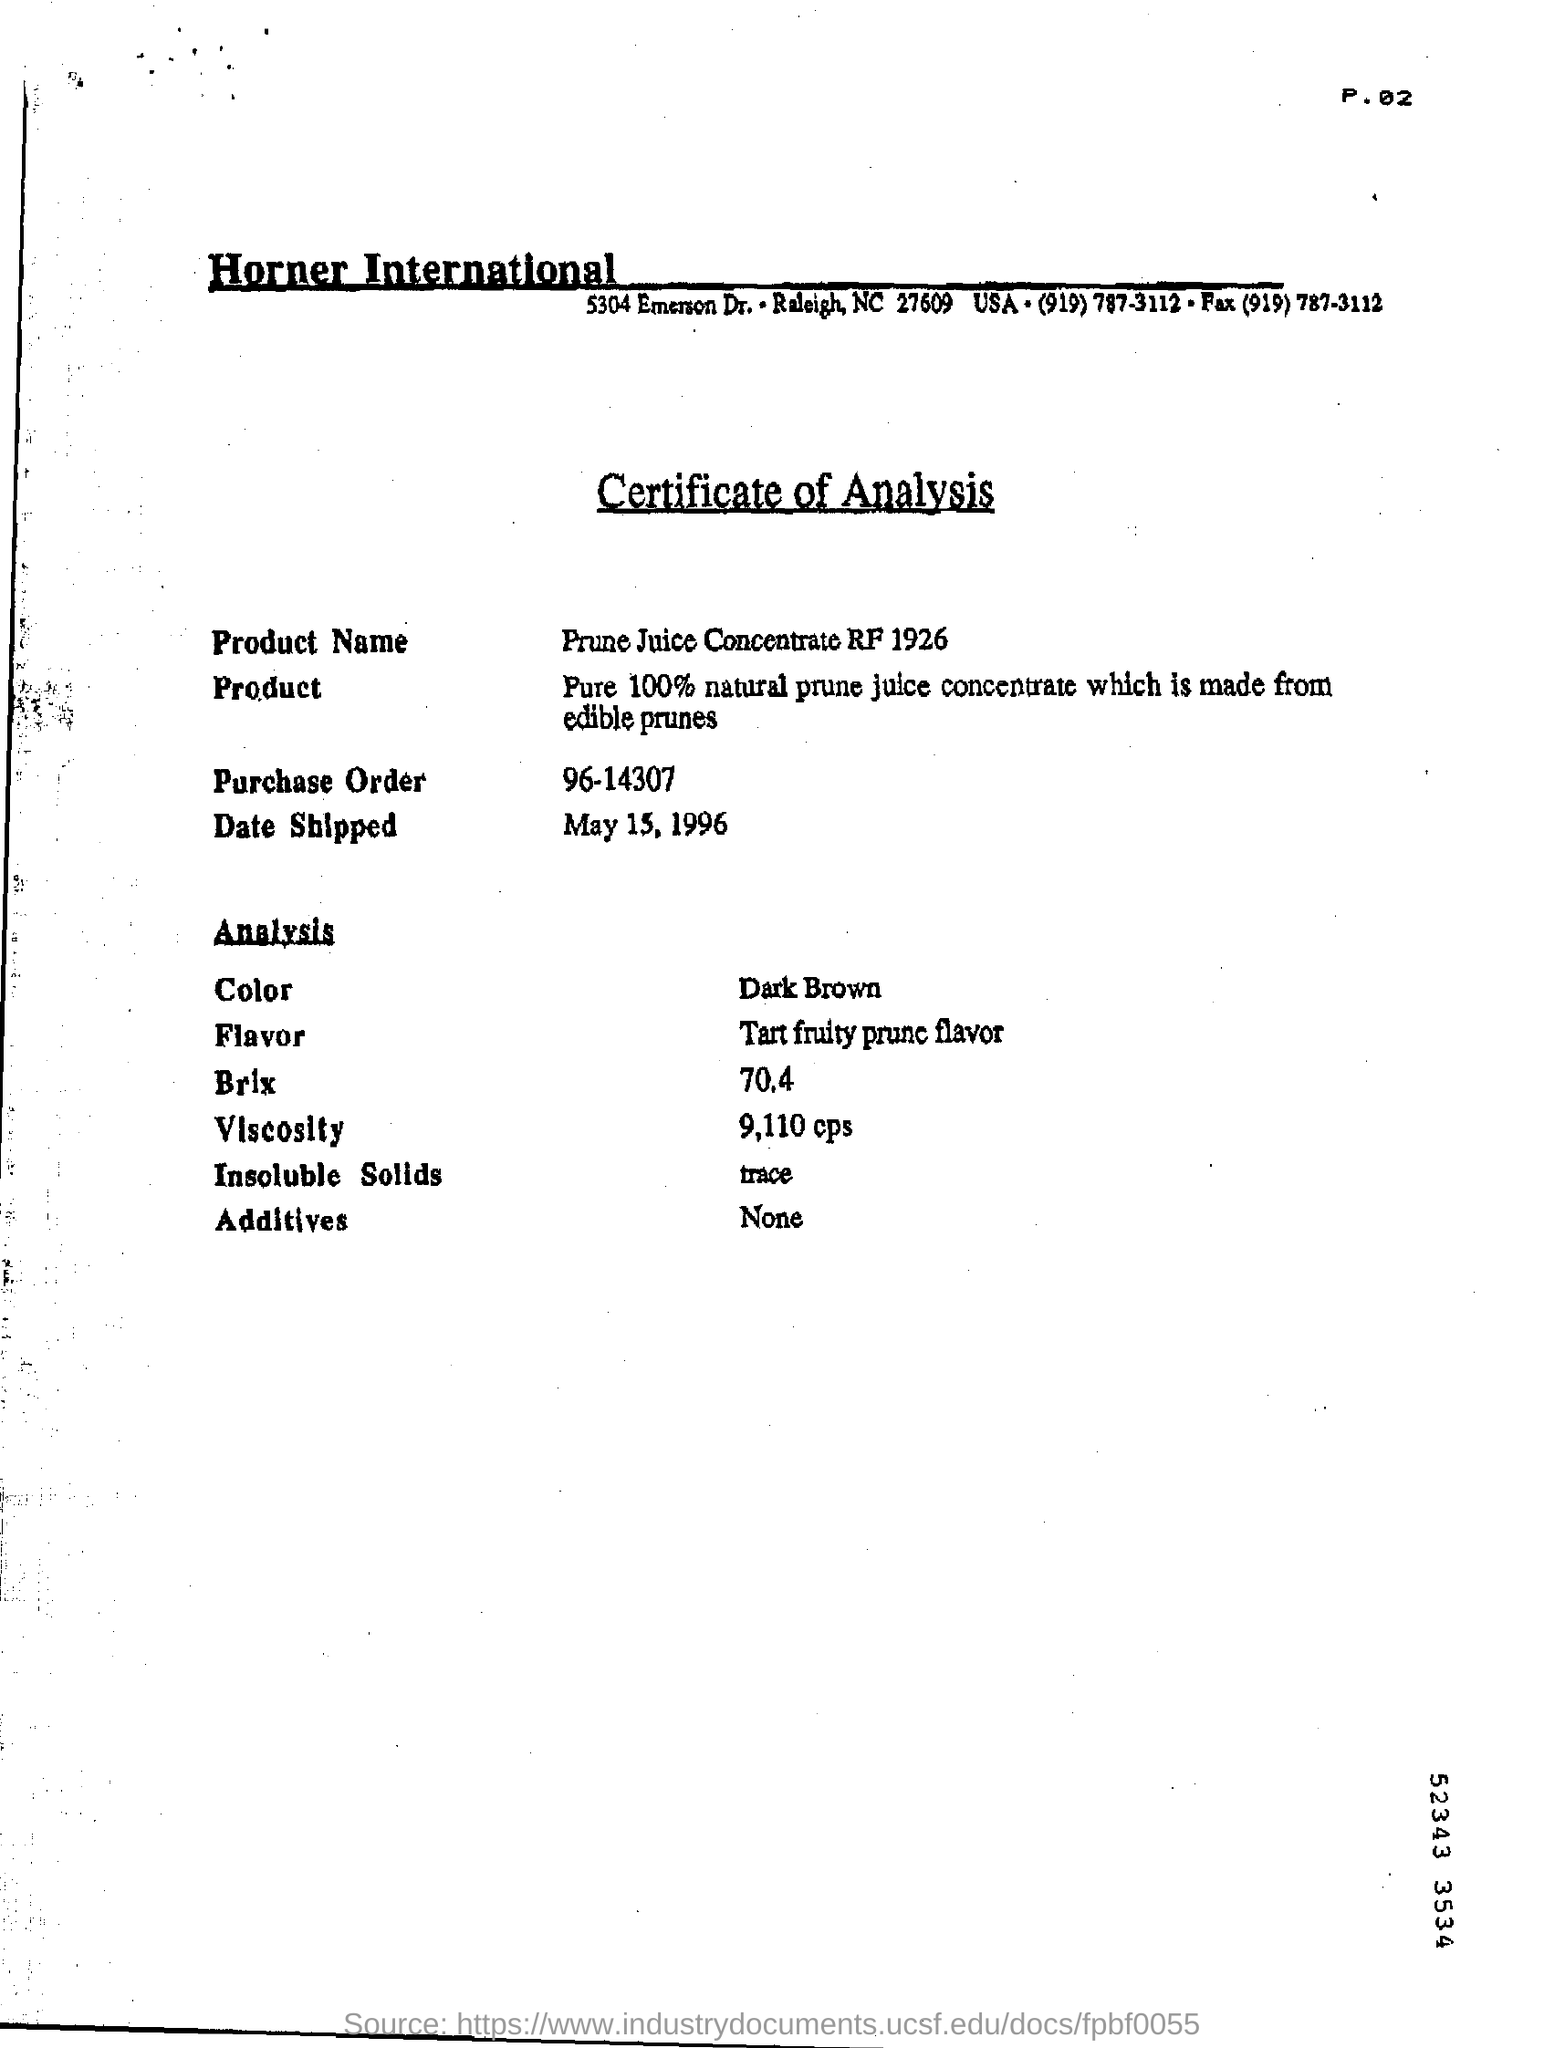Indicate a few pertinent items in this graphic. This is a document that certifies the analysis of a particular type of document. The product was shipped on May 15, 1996. The product shown in the analysis is dark brown in color. The page number mentioned in this document is P.02. The document contains a purchase order numbered 96-14307. 